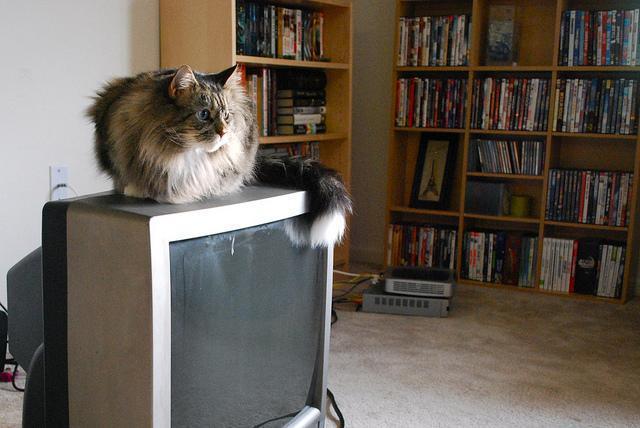What is the item that the cat is on top of used for?
Make your selection from the four choices given to correctly answer the question.
Options: Writing books, storing groceries, watching shows, cleaning floors. Watching shows. 